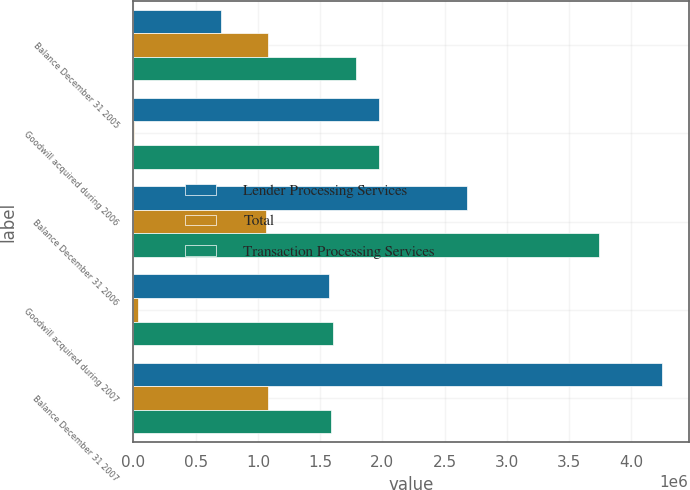Convert chart to OTSL. <chart><loc_0><loc_0><loc_500><loc_500><stacked_bar_chart><ecel><fcel>Balance December 31 2005<fcel>Goodwill acquired during 2006<fcel>Balance December 31 2006<fcel>Goodwill acquired during 2007<fcel>Balance December 31 2007<nl><fcel>Lender Processing Services<fcel>706432<fcel>1.96996e+06<fcel>2.67639e+06<fcel>1.57229e+06<fcel>4.24868e+06<nl><fcel>Total<fcel>1.08128e+06<fcel>210<fcel>1.06115e+06<fcel>34074<fcel>1.07815e+06<nl><fcel>Transaction Processing Services<fcel>1.78771e+06<fcel>1.97017e+06<fcel>3.73754e+06<fcel>1.60636e+06<fcel>1.58933e+06<nl></chart> 